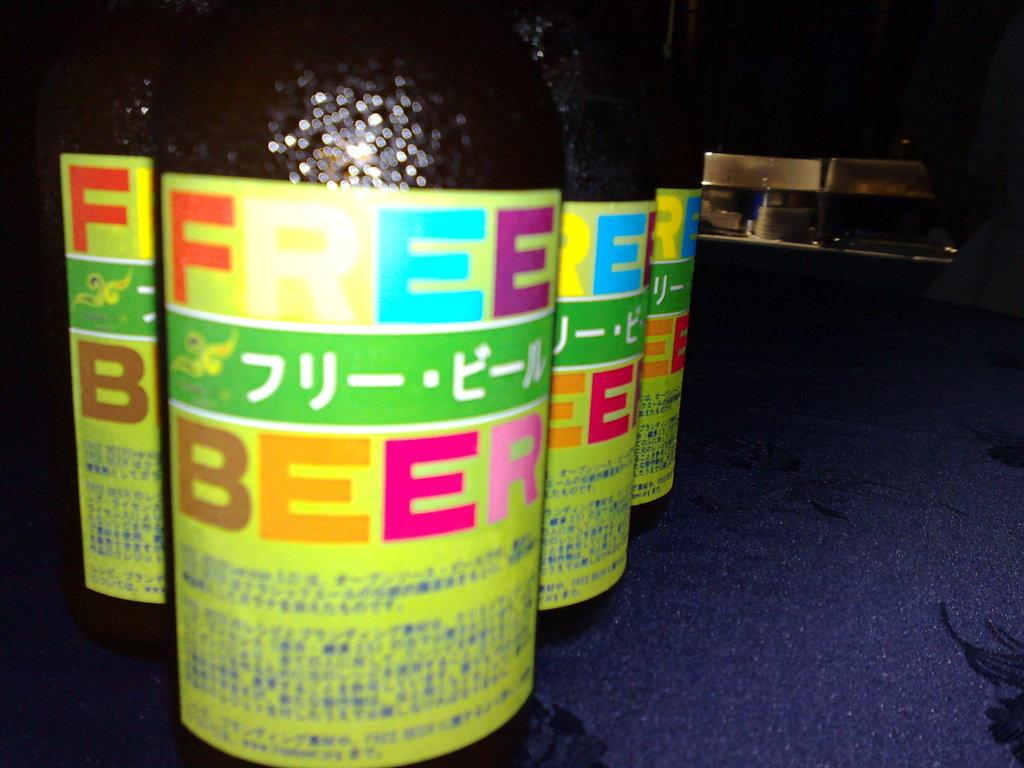<image>
Provide a brief description of the given image. Several bottles of Free Beer sit on a dark blue surface. 